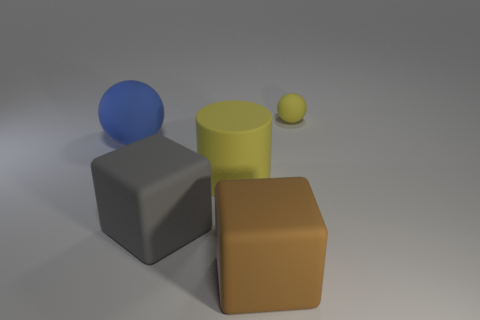There is a yellow object that is right of the rubber cylinder; is it the same shape as the yellow matte thing that is left of the tiny yellow rubber ball?
Keep it short and to the point. No. There is a yellow thing left of the cube in front of the big gray object; what shape is it?
Provide a succinct answer. Cylinder. There is a matte thing that is both to the left of the yellow cylinder and to the right of the large blue ball; what size is it?
Offer a very short reply. Large. Do the tiny rubber thing and the yellow matte thing in front of the blue thing have the same shape?
Your answer should be compact. No. What is the size of the yellow object that is the same shape as the large blue rubber thing?
Give a very brief answer. Small. Is the color of the small rubber object the same as the big block that is behind the big brown rubber thing?
Give a very brief answer. No. How many other objects are the same size as the yellow rubber sphere?
Keep it short and to the point. 0. What shape is the yellow thing in front of the thing behind the matte ball that is left of the tiny yellow thing?
Provide a succinct answer. Cylinder. Does the brown rubber thing have the same size as the matte ball that is on the right side of the big matte cylinder?
Keep it short and to the point. No. There is a big object that is left of the big yellow cylinder and on the right side of the big blue thing; what is its color?
Offer a terse response. Gray. 